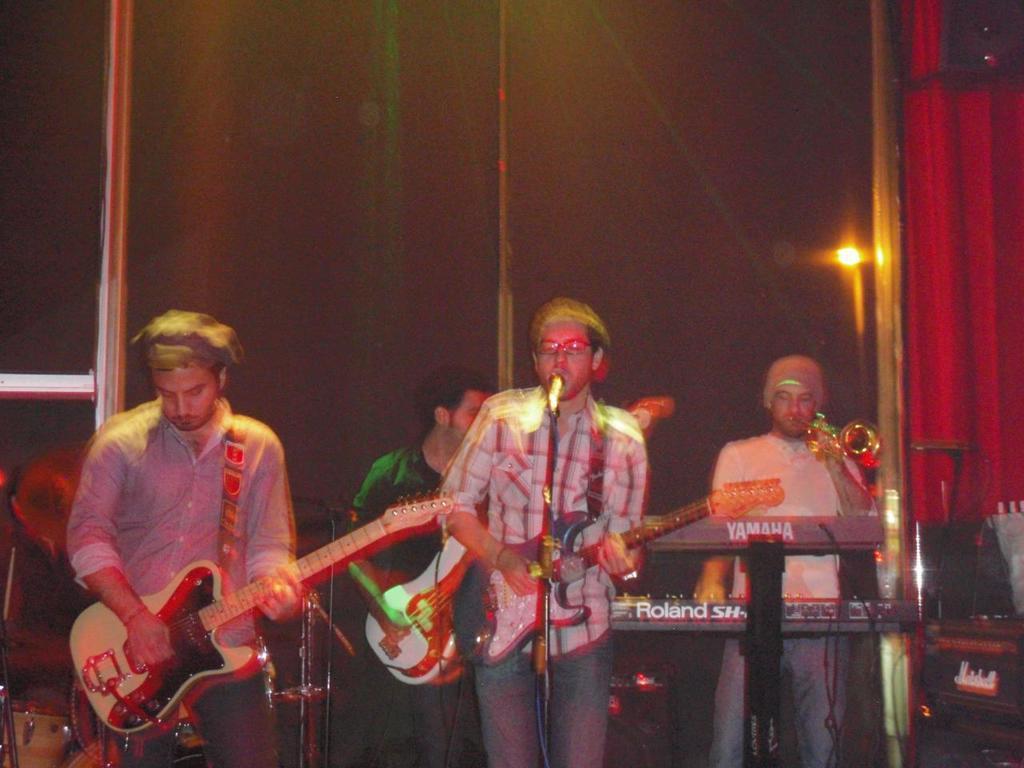Could you give a brief overview of what you see in this image? Here we can see four people performing musical instruments, the person on the right side is playing a piano and the remaining three persons are playing a guitar , the person in the middle is a singing a song with microphone in front of him 